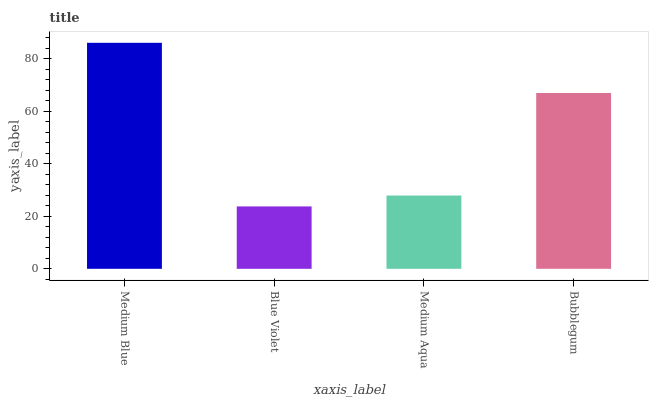Is Blue Violet the minimum?
Answer yes or no. Yes. Is Medium Blue the maximum?
Answer yes or no. Yes. Is Medium Aqua the minimum?
Answer yes or no. No. Is Medium Aqua the maximum?
Answer yes or no. No. Is Medium Aqua greater than Blue Violet?
Answer yes or no. Yes. Is Blue Violet less than Medium Aqua?
Answer yes or no. Yes. Is Blue Violet greater than Medium Aqua?
Answer yes or no. No. Is Medium Aqua less than Blue Violet?
Answer yes or no. No. Is Bubblegum the high median?
Answer yes or no. Yes. Is Medium Aqua the low median?
Answer yes or no. Yes. Is Blue Violet the high median?
Answer yes or no. No. Is Blue Violet the low median?
Answer yes or no. No. 